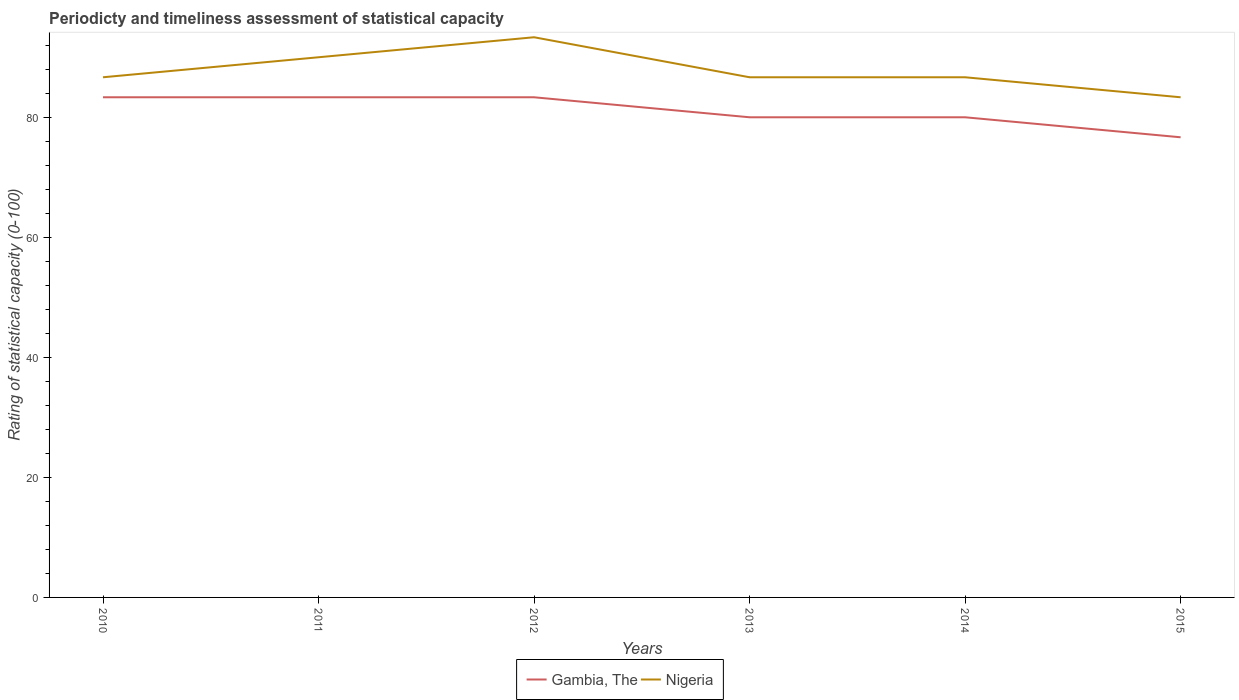Does the line corresponding to Nigeria intersect with the line corresponding to Gambia, The?
Give a very brief answer. No. Across all years, what is the maximum rating of statistical capacity in Nigeria?
Your response must be concise. 83.33. In which year was the rating of statistical capacity in Nigeria maximum?
Give a very brief answer. 2015. What is the total rating of statistical capacity in Gambia, The in the graph?
Your answer should be very brief. 0. What is the difference between the highest and the second highest rating of statistical capacity in Gambia, The?
Give a very brief answer. 6.67. Is the rating of statistical capacity in Gambia, The strictly greater than the rating of statistical capacity in Nigeria over the years?
Ensure brevity in your answer.  Yes. How many years are there in the graph?
Offer a very short reply. 6. What is the difference between two consecutive major ticks on the Y-axis?
Provide a succinct answer. 20. Does the graph contain any zero values?
Your answer should be compact. No. Does the graph contain grids?
Make the answer very short. No. How many legend labels are there?
Offer a terse response. 2. How are the legend labels stacked?
Provide a short and direct response. Horizontal. What is the title of the graph?
Ensure brevity in your answer.  Periodicty and timeliness assessment of statistical capacity. What is the label or title of the Y-axis?
Your response must be concise. Rating of statistical capacity (0-100). What is the Rating of statistical capacity (0-100) in Gambia, The in 2010?
Offer a very short reply. 83.33. What is the Rating of statistical capacity (0-100) in Nigeria in 2010?
Make the answer very short. 86.67. What is the Rating of statistical capacity (0-100) in Gambia, The in 2011?
Ensure brevity in your answer.  83.33. What is the Rating of statistical capacity (0-100) of Gambia, The in 2012?
Give a very brief answer. 83.33. What is the Rating of statistical capacity (0-100) of Nigeria in 2012?
Keep it short and to the point. 93.33. What is the Rating of statistical capacity (0-100) of Gambia, The in 2013?
Your answer should be very brief. 80. What is the Rating of statistical capacity (0-100) of Nigeria in 2013?
Your answer should be very brief. 86.67. What is the Rating of statistical capacity (0-100) of Nigeria in 2014?
Offer a very short reply. 86.67. What is the Rating of statistical capacity (0-100) of Gambia, The in 2015?
Give a very brief answer. 76.67. What is the Rating of statistical capacity (0-100) in Nigeria in 2015?
Offer a terse response. 83.33. Across all years, what is the maximum Rating of statistical capacity (0-100) in Gambia, The?
Make the answer very short. 83.33. Across all years, what is the maximum Rating of statistical capacity (0-100) of Nigeria?
Keep it short and to the point. 93.33. Across all years, what is the minimum Rating of statistical capacity (0-100) in Gambia, The?
Your answer should be compact. 76.67. Across all years, what is the minimum Rating of statistical capacity (0-100) of Nigeria?
Keep it short and to the point. 83.33. What is the total Rating of statistical capacity (0-100) of Gambia, The in the graph?
Give a very brief answer. 486.67. What is the total Rating of statistical capacity (0-100) in Nigeria in the graph?
Offer a terse response. 526.67. What is the difference between the Rating of statistical capacity (0-100) of Gambia, The in 2010 and that in 2011?
Give a very brief answer. 0. What is the difference between the Rating of statistical capacity (0-100) of Gambia, The in 2010 and that in 2012?
Provide a short and direct response. 0. What is the difference between the Rating of statistical capacity (0-100) in Nigeria in 2010 and that in 2012?
Your response must be concise. -6.67. What is the difference between the Rating of statistical capacity (0-100) in Gambia, The in 2010 and that in 2013?
Give a very brief answer. 3.33. What is the difference between the Rating of statistical capacity (0-100) of Nigeria in 2010 and that in 2013?
Give a very brief answer. 0. What is the difference between the Rating of statistical capacity (0-100) of Gambia, The in 2010 and that in 2015?
Keep it short and to the point. 6.67. What is the difference between the Rating of statistical capacity (0-100) in Nigeria in 2010 and that in 2015?
Keep it short and to the point. 3.33. What is the difference between the Rating of statistical capacity (0-100) in Gambia, The in 2011 and that in 2012?
Make the answer very short. 0. What is the difference between the Rating of statistical capacity (0-100) in Nigeria in 2011 and that in 2013?
Offer a terse response. 3.33. What is the difference between the Rating of statistical capacity (0-100) in Nigeria in 2011 and that in 2014?
Provide a succinct answer. 3.33. What is the difference between the Rating of statistical capacity (0-100) in Gambia, The in 2011 and that in 2015?
Your response must be concise. 6.67. What is the difference between the Rating of statistical capacity (0-100) of Gambia, The in 2012 and that in 2013?
Your answer should be very brief. 3.33. What is the difference between the Rating of statistical capacity (0-100) of Nigeria in 2012 and that in 2013?
Provide a succinct answer. 6.67. What is the difference between the Rating of statistical capacity (0-100) in Gambia, The in 2012 and that in 2014?
Ensure brevity in your answer.  3.33. What is the difference between the Rating of statistical capacity (0-100) in Gambia, The in 2012 and that in 2015?
Give a very brief answer. 6.67. What is the difference between the Rating of statistical capacity (0-100) in Gambia, The in 2013 and that in 2014?
Your response must be concise. 0. What is the difference between the Rating of statistical capacity (0-100) of Nigeria in 2013 and that in 2014?
Provide a succinct answer. 0. What is the difference between the Rating of statistical capacity (0-100) of Nigeria in 2013 and that in 2015?
Make the answer very short. 3.33. What is the difference between the Rating of statistical capacity (0-100) in Nigeria in 2014 and that in 2015?
Keep it short and to the point. 3.33. What is the difference between the Rating of statistical capacity (0-100) in Gambia, The in 2010 and the Rating of statistical capacity (0-100) in Nigeria in 2011?
Ensure brevity in your answer.  -6.67. What is the difference between the Rating of statistical capacity (0-100) of Gambia, The in 2010 and the Rating of statistical capacity (0-100) of Nigeria in 2013?
Offer a very short reply. -3.33. What is the difference between the Rating of statistical capacity (0-100) of Gambia, The in 2010 and the Rating of statistical capacity (0-100) of Nigeria in 2014?
Offer a terse response. -3.33. What is the difference between the Rating of statistical capacity (0-100) in Gambia, The in 2010 and the Rating of statistical capacity (0-100) in Nigeria in 2015?
Your answer should be compact. 0. What is the difference between the Rating of statistical capacity (0-100) in Gambia, The in 2011 and the Rating of statistical capacity (0-100) in Nigeria in 2012?
Offer a terse response. -10. What is the difference between the Rating of statistical capacity (0-100) of Gambia, The in 2011 and the Rating of statistical capacity (0-100) of Nigeria in 2013?
Keep it short and to the point. -3.33. What is the difference between the Rating of statistical capacity (0-100) of Gambia, The in 2011 and the Rating of statistical capacity (0-100) of Nigeria in 2014?
Ensure brevity in your answer.  -3.33. What is the difference between the Rating of statistical capacity (0-100) in Gambia, The in 2012 and the Rating of statistical capacity (0-100) in Nigeria in 2013?
Keep it short and to the point. -3.33. What is the difference between the Rating of statistical capacity (0-100) in Gambia, The in 2012 and the Rating of statistical capacity (0-100) in Nigeria in 2015?
Give a very brief answer. 0. What is the difference between the Rating of statistical capacity (0-100) in Gambia, The in 2013 and the Rating of statistical capacity (0-100) in Nigeria in 2014?
Keep it short and to the point. -6.67. What is the difference between the Rating of statistical capacity (0-100) of Gambia, The in 2013 and the Rating of statistical capacity (0-100) of Nigeria in 2015?
Give a very brief answer. -3.33. What is the difference between the Rating of statistical capacity (0-100) in Gambia, The in 2014 and the Rating of statistical capacity (0-100) in Nigeria in 2015?
Give a very brief answer. -3.33. What is the average Rating of statistical capacity (0-100) in Gambia, The per year?
Give a very brief answer. 81.11. What is the average Rating of statistical capacity (0-100) in Nigeria per year?
Your answer should be compact. 87.78. In the year 2011, what is the difference between the Rating of statistical capacity (0-100) in Gambia, The and Rating of statistical capacity (0-100) in Nigeria?
Provide a short and direct response. -6.67. In the year 2012, what is the difference between the Rating of statistical capacity (0-100) of Gambia, The and Rating of statistical capacity (0-100) of Nigeria?
Offer a very short reply. -10. In the year 2013, what is the difference between the Rating of statistical capacity (0-100) of Gambia, The and Rating of statistical capacity (0-100) of Nigeria?
Offer a very short reply. -6.67. In the year 2014, what is the difference between the Rating of statistical capacity (0-100) of Gambia, The and Rating of statistical capacity (0-100) of Nigeria?
Offer a very short reply. -6.67. In the year 2015, what is the difference between the Rating of statistical capacity (0-100) of Gambia, The and Rating of statistical capacity (0-100) of Nigeria?
Your answer should be compact. -6.67. What is the ratio of the Rating of statistical capacity (0-100) of Nigeria in 2010 to that in 2011?
Your response must be concise. 0.96. What is the ratio of the Rating of statistical capacity (0-100) in Gambia, The in 2010 to that in 2012?
Your answer should be very brief. 1. What is the ratio of the Rating of statistical capacity (0-100) of Nigeria in 2010 to that in 2012?
Your response must be concise. 0.93. What is the ratio of the Rating of statistical capacity (0-100) in Gambia, The in 2010 to that in 2013?
Offer a terse response. 1.04. What is the ratio of the Rating of statistical capacity (0-100) in Nigeria in 2010 to that in 2013?
Your response must be concise. 1. What is the ratio of the Rating of statistical capacity (0-100) in Gambia, The in 2010 to that in 2014?
Your answer should be compact. 1.04. What is the ratio of the Rating of statistical capacity (0-100) in Gambia, The in 2010 to that in 2015?
Provide a short and direct response. 1.09. What is the ratio of the Rating of statistical capacity (0-100) of Nigeria in 2010 to that in 2015?
Provide a succinct answer. 1.04. What is the ratio of the Rating of statistical capacity (0-100) of Nigeria in 2011 to that in 2012?
Provide a succinct answer. 0.96. What is the ratio of the Rating of statistical capacity (0-100) in Gambia, The in 2011 to that in 2013?
Your response must be concise. 1.04. What is the ratio of the Rating of statistical capacity (0-100) in Gambia, The in 2011 to that in 2014?
Provide a short and direct response. 1.04. What is the ratio of the Rating of statistical capacity (0-100) of Gambia, The in 2011 to that in 2015?
Offer a terse response. 1.09. What is the ratio of the Rating of statistical capacity (0-100) of Nigeria in 2011 to that in 2015?
Keep it short and to the point. 1.08. What is the ratio of the Rating of statistical capacity (0-100) in Gambia, The in 2012 to that in 2013?
Give a very brief answer. 1.04. What is the ratio of the Rating of statistical capacity (0-100) in Nigeria in 2012 to that in 2013?
Your answer should be very brief. 1.08. What is the ratio of the Rating of statistical capacity (0-100) in Gambia, The in 2012 to that in 2014?
Keep it short and to the point. 1.04. What is the ratio of the Rating of statistical capacity (0-100) of Gambia, The in 2012 to that in 2015?
Your answer should be compact. 1.09. What is the ratio of the Rating of statistical capacity (0-100) of Nigeria in 2012 to that in 2015?
Provide a succinct answer. 1.12. What is the ratio of the Rating of statistical capacity (0-100) in Gambia, The in 2013 to that in 2014?
Make the answer very short. 1. What is the ratio of the Rating of statistical capacity (0-100) in Nigeria in 2013 to that in 2014?
Provide a short and direct response. 1. What is the ratio of the Rating of statistical capacity (0-100) in Gambia, The in 2013 to that in 2015?
Give a very brief answer. 1.04. What is the ratio of the Rating of statistical capacity (0-100) of Nigeria in 2013 to that in 2015?
Ensure brevity in your answer.  1.04. What is the ratio of the Rating of statistical capacity (0-100) of Gambia, The in 2014 to that in 2015?
Ensure brevity in your answer.  1.04. What is the ratio of the Rating of statistical capacity (0-100) of Nigeria in 2014 to that in 2015?
Keep it short and to the point. 1.04. What is the difference between the highest and the second highest Rating of statistical capacity (0-100) in Nigeria?
Your response must be concise. 3.33. What is the difference between the highest and the lowest Rating of statistical capacity (0-100) of Gambia, The?
Provide a succinct answer. 6.67. 